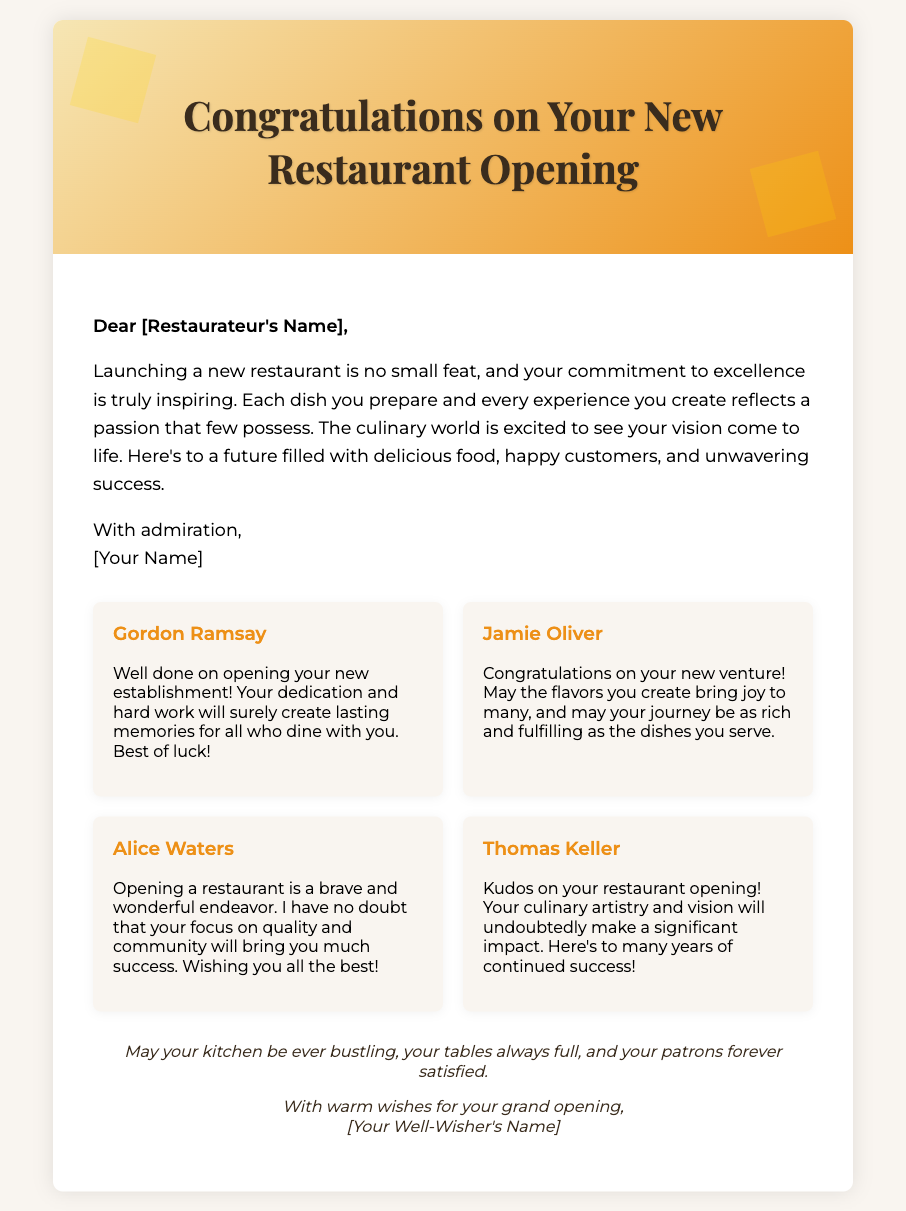What is the title of the card? The title is prominently displayed at the top of the card in an elegant font.
Answer: Congratulations on Your New Restaurant Opening Who is the message addressed to? The greeting card begins with a personal message directed to the restaurateur.
Answer: Dear [Restaurateur's Name] Which culinary expert congratulates the restaurateur by emphasizing hard work? The note from a culinary expert mentions dedication and hard work in relation to the opening.
Answer: Gordon Ramsay What color is the background of the cover section? The cover section features a linear gradient with specific colors that set the theme.
Answer: Gradient yellow to orange Name one quality the card emphasizes about the restaurateur. The card highlights a specific dedication that is crucial in the culinary world.
Answer: Commitment to excellence How many wishes are presented from industry peers? There are multiple congratulatory messages included from notable chefs.
Answer: Four wishes What is said about the future of the restaurateur’s venture? The card expresses positive sentiments regarding upcoming experiences and success.
Answer: Filled with delicious food, happy customers, and unwavering success What is the overall theme of the card? The theme revolves around celebrating achievements in the restaurant industry.
Answer: Congratulations and encouragement What is the visual design element used to enhance the card? There are embellishments that add a touch of elegance to the card's appearance.
Answer: Gold leaf embellishments 